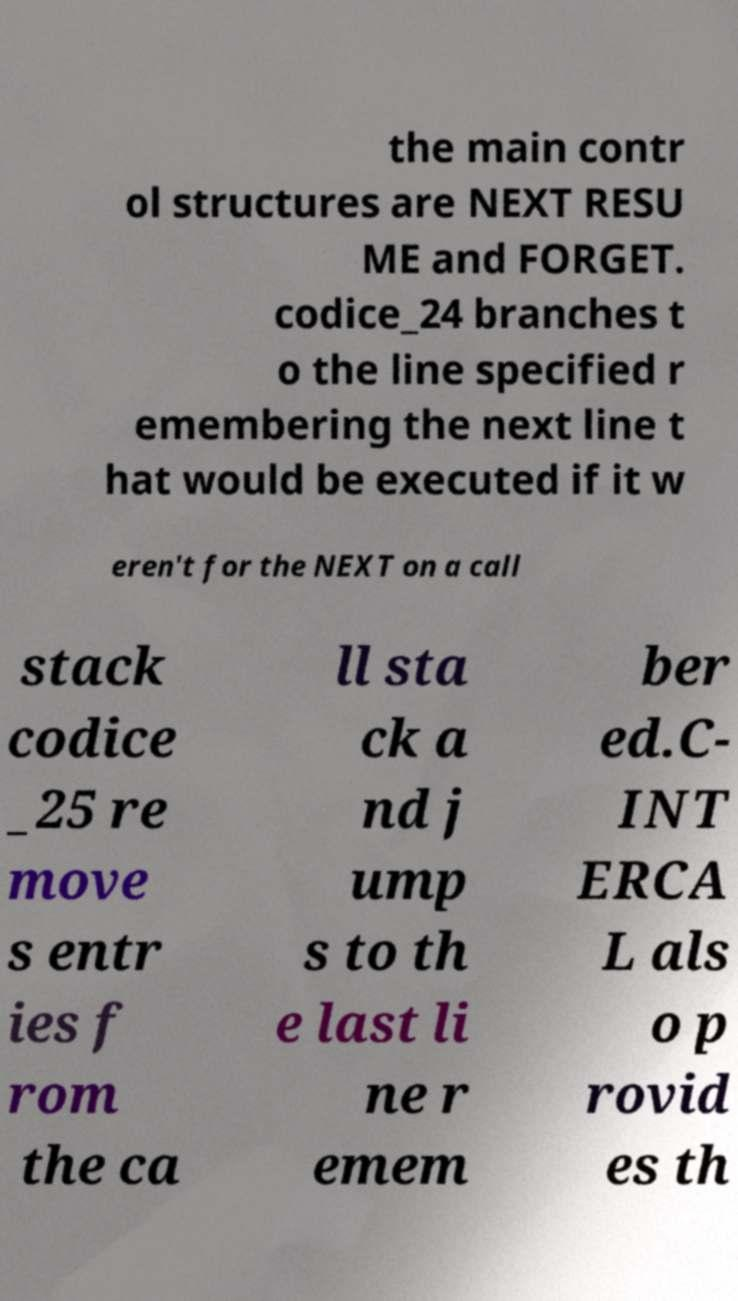Could you extract and type out the text from this image? the main contr ol structures are NEXT RESU ME and FORGET. codice_24 branches t o the line specified r emembering the next line t hat would be executed if it w eren't for the NEXT on a call stack codice _25 re move s entr ies f rom the ca ll sta ck a nd j ump s to th e last li ne r emem ber ed.C- INT ERCA L als o p rovid es th 